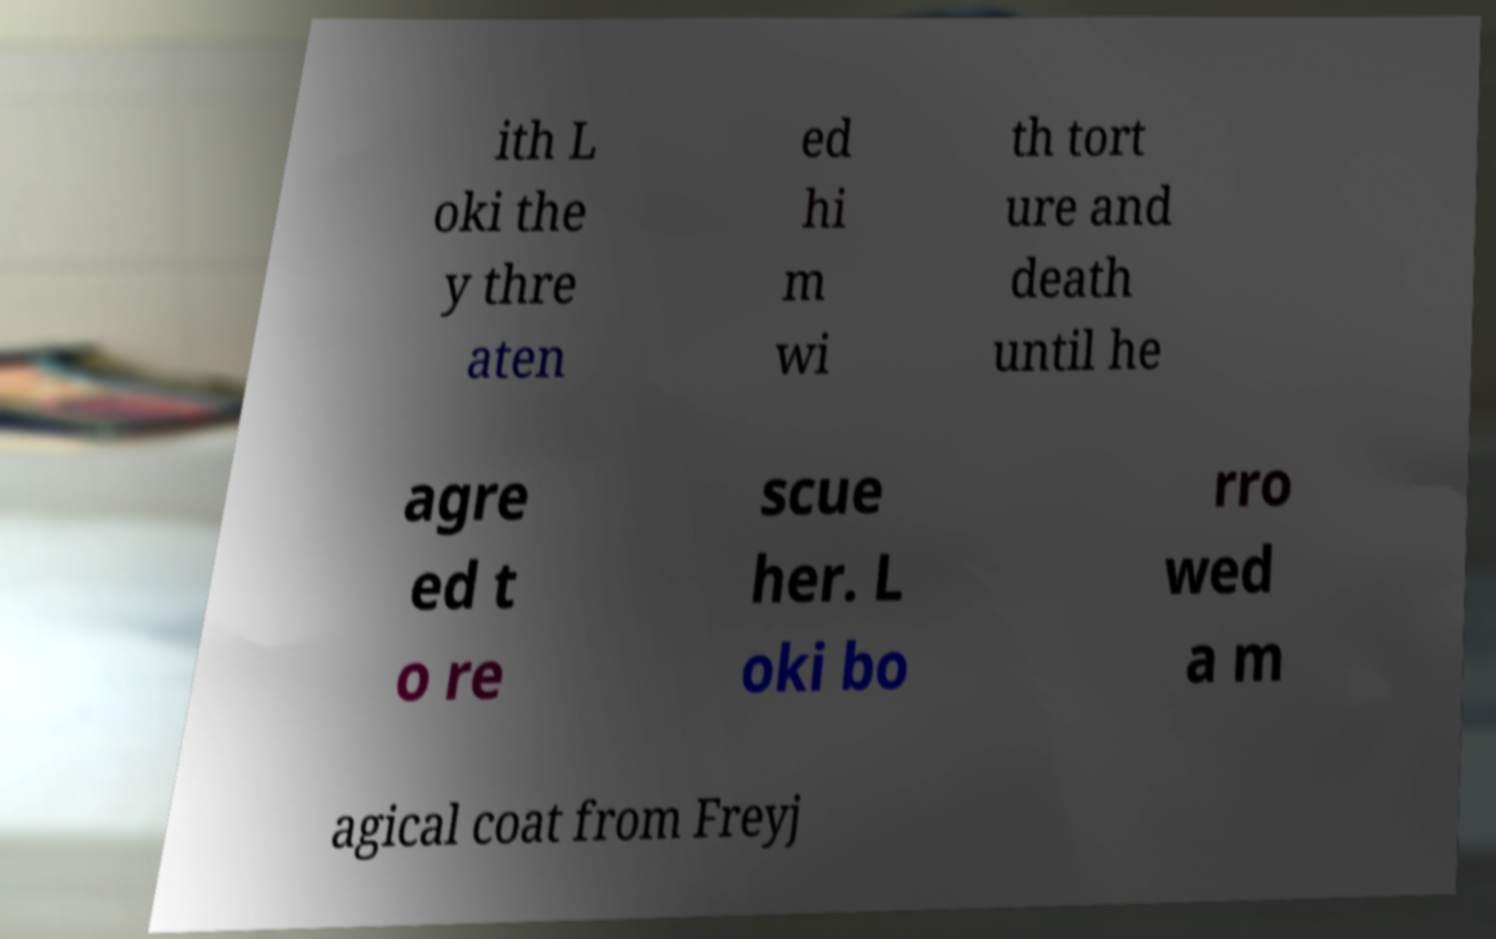Can you read and provide the text displayed in the image?This photo seems to have some interesting text. Can you extract and type it out for me? ith L oki the y thre aten ed hi m wi th tort ure and death until he agre ed t o re scue her. L oki bo rro wed a m agical coat from Freyj 